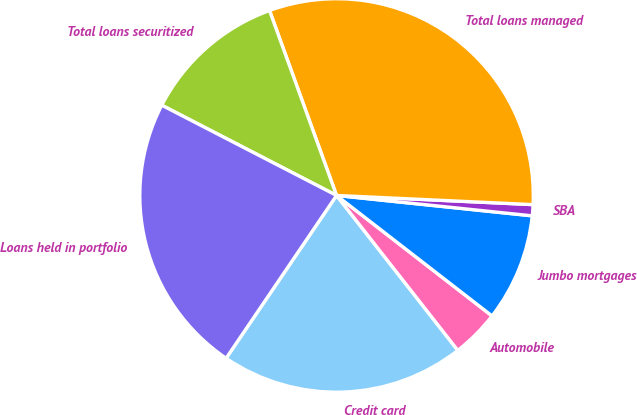<chart> <loc_0><loc_0><loc_500><loc_500><pie_chart><fcel>Credit card<fcel>Automobile<fcel>Jumbo mortgages<fcel>SBA<fcel>Total loans managed<fcel>Total loans securitized<fcel>Loans held in portfolio<nl><fcel>20.06%<fcel>3.94%<fcel>8.84%<fcel>0.91%<fcel>31.28%<fcel>11.88%<fcel>23.1%<nl></chart> 